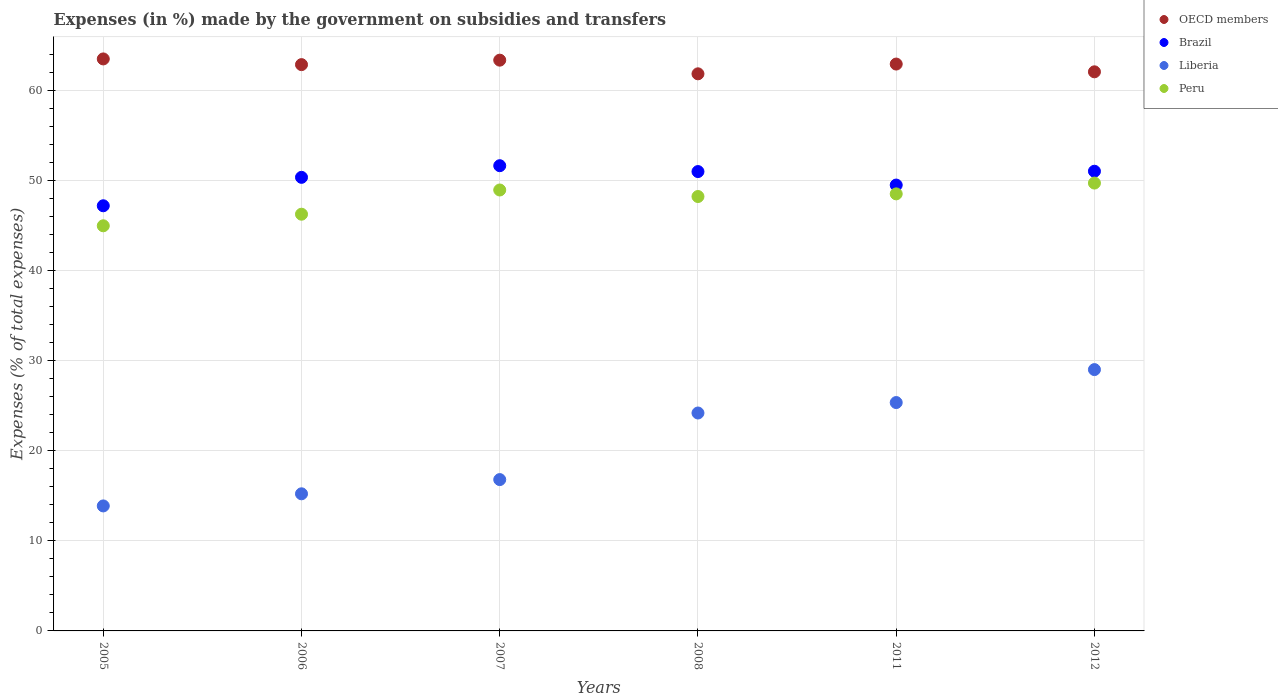How many different coloured dotlines are there?
Make the answer very short. 4. What is the percentage of expenses made by the government on subsidies and transfers in OECD members in 2005?
Your response must be concise. 63.48. Across all years, what is the maximum percentage of expenses made by the government on subsidies and transfers in Brazil?
Offer a very short reply. 51.63. Across all years, what is the minimum percentage of expenses made by the government on subsidies and transfers in Liberia?
Keep it short and to the point. 13.87. In which year was the percentage of expenses made by the government on subsidies and transfers in OECD members maximum?
Your answer should be compact. 2005. In which year was the percentage of expenses made by the government on subsidies and transfers in Liberia minimum?
Your answer should be compact. 2005. What is the total percentage of expenses made by the government on subsidies and transfers in Peru in the graph?
Your answer should be very brief. 286.57. What is the difference between the percentage of expenses made by the government on subsidies and transfers in Brazil in 2005 and that in 2006?
Provide a succinct answer. -3.16. What is the difference between the percentage of expenses made by the government on subsidies and transfers in OECD members in 2012 and the percentage of expenses made by the government on subsidies and transfers in Brazil in 2007?
Provide a short and direct response. 10.42. What is the average percentage of expenses made by the government on subsidies and transfers in Brazil per year?
Give a very brief answer. 50.11. In the year 2006, what is the difference between the percentage of expenses made by the government on subsidies and transfers in OECD members and percentage of expenses made by the government on subsidies and transfers in Brazil?
Your answer should be compact. 12.51. What is the ratio of the percentage of expenses made by the government on subsidies and transfers in OECD members in 2005 to that in 2006?
Offer a very short reply. 1.01. What is the difference between the highest and the second highest percentage of expenses made by the government on subsidies and transfers in Liberia?
Give a very brief answer. 3.66. What is the difference between the highest and the lowest percentage of expenses made by the government on subsidies and transfers in Peru?
Give a very brief answer. 4.74. Is the sum of the percentage of expenses made by the government on subsidies and transfers in OECD members in 2007 and 2008 greater than the maximum percentage of expenses made by the government on subsidies and transfers in Peru across all years?
Make the answer very short. Yes. Does the percentage of expenses made by the government on subsidies and transfers in Brazil monotonically increase over the years?
Your response must be concise. No. Is the percentage of expenses made by the government on subsidies and transfers in Peru strictly less than the percentage of expenses made by the government on subsidies and transfers in OECD members over the years?
Your response must be concise. Yes. Does the graph contain grids?
Offer a terse response. Yes. How are the legend labels stacked?
Give a very brief answer. Vertical. What is the title of the graph?
Offer a very short reply. Expenses (in %) made by the government on subsidies and transfers. Does "Ghana" appear as one of the legend labels in the graph?
Ensure brevity in your answer.  No. What is the label or title of the X-axis?
Offer a very short reply. Years. What is the label or title of the Y-axis?
Offer a terse response. Expenses (% of total expenses). What is the Expenses (% of total expenses) of OECD members in 2005?
Make the answer very short. 63.48. What is the Expenses (% of total expenses) of Brazil in 2005?
Keep it short and to the point. 47.18. What is the Expenses (% of total expenses) of Liberia in 2005?
Make the answer very short. 13.87. What is the Expenses (% of total expenses) in Peru in 2005?
Ensure brevity in your answer.  44.96. What is the Expenses (% of total expenses) in OECD members in 2006?
Provide a short and direct response. 62.85. What is the Expenses (% of total expenses) in Brazil in 2006?
Give a very brief answer. 50.34. What is the Expenses (% of total expenses) of Liberia in 2006?
Provide a succinct answer. 15.22. What is the Expenses (% of total expenses) in Peru in 2006?
Your answer should be very brief. 46.25. What is the Expenses (% of total expenses) of OECD members in 2007?
Offer a very short reply. 63.35. What is the Expenses (% of total expenses) in Brazil in 2007?
Offer a very short reply. 51.63. What is the Expenses (% of total expenses) in Liberia in 2007?
Make the answer very short. 16.8. What is the Expenses (% of total expenses) in Peru in 2007?
Your answer should be compact. 48.94. What is the Expenses (% of total expenses) in OECD members in 2008?
Offer a terse response. 61.83. What is the Expenses (% of total expenses) of Brazil in 2008?
Make the answer very short. 50.98. What is the Expenses (% of total expenses) of Liberia in 2008?
Offer a terse response. 24.19. What is the Expenses (% of total expenses) in Peru in 2008?
Keep it short and to the point. 48.21. What is the Expenses (% of total expenses) of OECD members in 2011?
Provide a succinct answer. 62.91. What is the Expenses (% of total expenses) of Brazil in 2011?
Your answer should be compact. 49.48. What is the Expenses (% of total expenses) of Liberia in 2011?
Your response must be concise. 25.34. What is the Expenses (% of total expenses) in Peru in 2011?
Give a very brief answer. 48.5. What is the Expenses (% of total expenses) in OECD members in 2012?
Provide a short and direct response. 62.05. What is the Expenses (% of total expenses) in Brazil in 2012?
Your response must be concise. 51.02. What is the Expenses (% of total expenses) of Liberia in 2012?
Offer a terse response. 29. What is the Expenses (% of total expenses) of Peru in 2012?
Make the answer very short. 49.7. Across all years, what is the maximum Expenses (% of total expenses) of OECD members?
Your answer should be compact. 63.48. Across all years, what is the maximum Expenses (% of total expenses) in Brazil?
Offer a terse response. 51.63. Across all years, what is the maximum Expenses (% of total expenses) in Liberia?
Offer a very short reply. 29. Across all years, what is the maximum Expenses (% of total expenses) of Peru?
Give a very brief answer. 49.7. Across all years, what is the minimum Expenses (% of total expenses) in OECD members?
Offer a terse response. 61.83. Across all years, what is the minimum Expenses (% of total expenses) of Brazil?
Keep it short and to the point. 47.18. Across all years, what is the minimum Expenses (% of total expenses) in Liberia?
Make the answer very short. 13.87. Across all years, what is the minimum Expenses (% of total expenses) of Peru?
Offer a very short reply. 44.96. What is the total Expenses (% of total expenses) of OECD members in the graph?
Keep it short and to the point. 376.47. What is the total Expenses (% of total expenses) in Brazil in the graph?
Make the answer very short. 300.64. What is the total Expenses (% of total expenses) in Liberia in the graph?
Offer a terse response. 124.42. What is the total Expenses (% of total expenses) in Peru in the graph?
Give a very brief answer. 286.57. What is the difference between the Expenses (% of total expenses) of OECD members in 2005 and that in 2006?
Offer a very short reply. 0.63. What is the difference between the Expenses (% of total expenses) of Brazil in 2005 and that in 2006?
Provide a short and direct response. -3.16. What is the difference between the Expenses (% of total expenses) in Liberia in 2005 and that in 2006?
Keep it short and to the point. -1.35. What is the difference between the Expenses (% of total expenses) in Peru in 2005 and that in 2006?
Provide a short and direct response. -1.29. What is the difference between the Expenses (% of total expenses) in OECD members in 2005 and that in 2007?
Give a very brief answer. 0.14. What is the difference between the Expenses (% of total expenses) of Brazil in 2005 and that in 2007?
Your response must be concise. -4.45. What is the difference between the Expenses (% of total expenses) of Liberia in 2005 and that in 2007?
Ensure brevity in your answer.  -2.92. What is the difference between the Expenses (% of total expenses) of Peru in 2005 and that in 2007?
Your answer should be very brief. -3.97. What is the difference between the Expenses (% of total expenses) in OECD members in 2005 and that in 2008?
Your answer should be compact. 1.65. What is the difference between the Expenses (% of total expenses) of Brazil in 2005 and that in 2008?
Keep it short and to the point. -3.8. What is the difference between the Expenses (% of total expenses) of Liberia in 2005 and that in 2008?
Your response must be concise. -10.31. What is the difference between the Expenses (% of total expenses) in Peru in 2005 and that in 2008?
Ensure brevity in your answer.  -3.25. What is the difference between the Expenses (% of total expenses) of OECD members in 2005 and that in 2011?
Offer a terse response. 0.57. What is the difference between the Expenses (% of total expenses) of Brazil in 2005 and that in 2011?
Make the answer very short. -2.3. What is the difference between the Expenses (% of total expenses) in Liberia in 2005 and that in 2011?
Make the answer very short. -11.47. What is the difference between the Expenses (% of total expenses) in Peru in 2005 and that in 2011?
Provide a short and direct response. -3.54. What is the difference between the Expenses (% of total expenses) of OECD members in 2005 and that in 2012?
Provide a short and direct response. 1.43. What is the difference between the Expenses (% of total expenses) of Brazil in 2005 and that in 2012?
Provide a succinct answer. -3.83. What is the difference between the Expenses (% of total expenses) of Liberia in 2005 and that in 2012?
Provide a succinct answer. -15.13. What is the difference between the Expenses (% of total expenses) of Peru in 2005 and that in 2012?
Your answer should be very brief. -4.74. What is the difference between the Expenses (% of total expenses) in OECD members in 2006 and that in 2007?
Offer a terse response. -0.5. What is the difference between the Expenses (% of total expenses) in Brazil in 2006 and that in 2007?
Provide a succinct answer. -1.29. What is the difference between the Expenses (% of total expenses) of Liberia in 2006 and that in 2007?
Provide a short and direct response. -1.58. What is the difference between the Expenses (% of total expenses) in Peru in 2006 and that in 2007?
Ensure brevity in your answer.  -2.69. What is the difference between the Expenses (% of total expenses) of OECD members in 2006 and that in 2008?
Your response must be concise. 1.02. What is the difference between the Expenses (% of total expenses) in Brazil in 2006 and that in 2008?
Offer a terse response. -0.64. What is the difference between the Expenses (% of total expenses) in Liberia in 2006 and that in 2008?
Offer a very short reply. -8.97. What is the difference between the Expenses (% of total expenses) in Peru in 2006 and that in 2008?
Your answer should be very brief. -1.96. What is the difference between the Expenses (% of total expenses) of OECD members in 2006 and that in 2011?
Give a very brief answer. -0.06. What is the difference between the Expenses (% of total expenses) of Brazil in 2006 and that in 2011?
Your answer should be very brief. 0.86. What is the difference between the Expenses (% of total expenses) in Liberia in 2006 and that in 2011?
Ensure brevity in your answer.  -10.13. What is the difference between the Expenses (% of total expenses) of Peru in 2006 and that in 2011?
Your response must be concise. -2.26. What is the difference between the Expenses (% of total expenses) of OECD members in 2006 and that in 2012?
Your answer should be compact. 0.8. What is the difference between the Expenses (% of total expenses) in Brazil in 2006 and that in 2012?
Your answer should be compact. -0.68. What is the difference between the Expenses (% of total expenses) in Liberia in 2006 and that in 2012?
Give a very brief answer. -13.79. What is the difference between the Expenses (% of total expenses) in Peru in 2006 and that in 2012?
Make the answer very short. -3.46. What is the difference between the Expenses (% of total expenses) of OECD members in 2007 and that in 2008?
Provide a succinct answer. 1.52. What is the difference between the Expenses (% of total expenses) in Brazil in 2007 and that in 2008?
Provide a succinct answer. 0.65. What is the difference between the Expenses (% of total expenses) of Liberia in 2007 and that in 2008?
Provide a short and direct response. -7.39. What is the difference between the Expenses (% of total expenses) of Peru in 2007 and that in 2008?
Make the answer very short. 0.72. What is the difference between the Expenses (% of total expenses) of OECD members in 2007 and that in 2011?
Ensure brevity in your answer.  0.43. What is the difference between the Expenses (% of total expenses) of Brazil in 2007 and that in 2011?
Give a very brief answer. 2.15. What is the difference between the Expenses (% of total expenses) in Liberia in 2007 and that in 2011?
Provide a succinct answer. -8.55. What is the difference between the Expenses (% of total expenses) of Peru in 2007 and that in 2011?
Your answer should be compact. 0.43. What is the difference between the Expenses (% of total expenses) in OECD members in 2007 and that in 2012?
Give a very brief answer. 1.29. What is the difference between the Expenses (% of total expenses) in Brazil in 2007 and that in 2012?
Provide a short and direct response. 0.61. What is the difference between the Expenses (% of total expenses) of Liberia in 2007 and that in 2012?
Provide a succinct answer. -12.21. What is the difference between the Expenses (% of total expenses) of Peru in 2007 and that in 2012?
Ensure brevity in your answer.  -0.77. What is the difference between the Expenses (% of total expenses) of OECD members in 2008 and that in 2011?
Your response must be concise. -1.08. What is the difference between the Expenses (% of total expenses) of Brazil in 2008 and that in 2011?
Your response must be concise. 1.5. What is the difference between the Expenses (% of total expenses) of Liberia in 2008 and that in 2011?
Provide a short and direct response. -1.16. What is the difference between the Expenses (% of total expenses) in Peru in 2008 and that in 2011?
Offer a terse response. -0.29. What is the difference between the Expenses (% of total expenses) in OECD members in 2008 and that in 2012?
Your answer should be compact. -0.22. What is the difference between the Expenses (% of total expenses) of Brazil in 2008 and that in 2012?
Make the answer very short. -0.04. What is the difference between the Expenses (% of total expenses) of Liberia in 2008 and that in 2012?
Make the answer very short. -4.82. What is the difference between the Expenses (% of total expenses) of Peru in 2008 and that in 2012?
Ensure brevity in your answer.  -1.49. What is the difference between the Expenses (% of total expenses) in OECD members in 2011 and that in 2012?
Provide a short and direct response. 0.86. What is the difference between the Expenses (% of total expenses) in Brazil in 2011 and that in 2012?
Give a very brief answer. -1.53. What is the difference between the Expenses (% of total expenses) in Liberia in 2011 and that in 2012?
Offer a terse response. -3.66. What is the difference between the Expenses (% of total expenses) in Peru in 2011 and that in 2012?
Provide a short and direct response. -1.2. What is the difference between the Expenses (% of total expenses) in OECD members in 2005 and the Expenses (% of total expenses) in Brazil in 2006?
Make the answer very short. 13.14. What is the difference between the Expenses (% of total expenses) of OECD members in 2005 and the Expenses (% of total expenses) of Liberia in 2006?
Your answer should be very brief. 48.26. What is the difference between the Expenses (% of total expenses) of OECD members in 2005 and the Expenses (% of total expenses) of Peru in 2006?
Your answer should be compact. 17.23. What is the difference between the Expenses (% of total expenses) in Brazil in 2005 and the Expenses (% of total expenses) in Liberia in 2006?
Keep it short and to the point. 31.97. What is the difference between the Expenses (% of total expenses) in Brazil in 2005 and the Expenses (% of total expenses) in Peru in 2006?
Make the answer very short. 0.94. What is the difference between the Expenses (% of total expenses) of Liberia in 2005 and the Expenses (% of total expenses) of Peru in 2006?
Keep it short and to the point. -32.38. What is the difference between the Expenses (% of total expenses) in OECD members in 2005 and the Expenses (% of total expenses) in Brazil in 2007?
Make the answer very short. 11.85. What is the difference between the Expenses (% of total expenses) of OECD members in 2005 and the Expenses (% of total expenses) of Liberia in 2007?
Provide a short and direct response. 46.69. What is the difference between the Expenses (% of total expenses) in OECD members in 2005 and the Expenses (% of total expenses) in Peru in 2007?
Make the answer very short. 14.55. What is the difference between the Expenses (% of total expenses) in Brazil in 2005 and the Expenses (% of total expenses) in Liberia in 2007?
Your answer should be very brief. 30.39. What is the difference between the Expenses (% of total expenses) in Brazil in 2005 and the Expenses (% of total expenses) in Peru in 2007?
Your answer should be very brief. -1.75. What is the difference between the Expenses (% of total expenses) in Liberia in 2005 and the Expenses (% of total expenses) in Peru in 2007?
Your answer should be very brief. -35.06. What is the difference between the Expenses (% of total expenses) of OECD members in 2005 and the Expenses (% of total expenses) of Brazil in 2008?
Your response must be concise. 12.5. What is the difference between the Expenses (% of total expenses) in OECD members in 2005 and the Expenses (% of total expenses) in Liberia in 2008?
Keep it short and to the point. 39.3. What is the difference between the Expenses (% of total expenses) in OECD members in 2005 and the Expenses (% of total expenses) in Peru in 2008?
Your answer should be very brief. 15.27. What is the difference between the Expenses (% of total expenses) of Brazil in 2005 and the Expenses (% of total expenses) of Liberia in 2008?
Make the answer very short. 23. What is the difference between the Expenses (% of total expenses) in Brazil in 2005 and the Expenses (% of total expenses) in Peru in 2008?
Your answer should be very brief. -1.03. What is the difference between the Expenses (% of total expenses) of Liberia in 2005 and the Expenses (% of total expenses) of Peru in 2008?
Keep it short and to the point. -34.34. What is the difference between the Expenses (% of total expenses) of OECD members in 2005 and the Expenses (% of total expenses) of Brazil in 2011?
Your answer should be very brief. 14. What is the difference between the Expenses (% of total expenses) of OECD members in 2005 and the Expenses (% of total expenses) of Liberia in 2011?
Your answer should be compact. 38.14. What is the difference between the Expenses (% of total expenses) in OECD members in 2005 and the Expenses (% of total expenses) in Peru in 2011?
Give a very brief answer. 14.98. What is the difference between the Expenses (% of total expenses) in Brazil in 2005 and the Expenses (% of total expenses) in Liberia in 2011?
Provide a short and direct response. 21.84. What is the difference between the Expenses (% of total expenses) of Brazil in 2005 and the Expenses (% of total expenses) of Peru in 2011?
Provide a short and direct response. -1.32. What is the difference between the Expenses (% of total expenses) of Liberia in 2005 and the Expenses (% of total expenses) of Peru in 2011?
Offer a very short reply. -34.63. What is the difference between the Expenses (% of total expenses) in OECD members in 2005 and the Expenses (% of total expenses) in Brazil in 2012?
Provide a short and direct response. 12.46. What is the difference between the Expenses (% of total expenses) of OECD members in 2005 and the Expenses (% of total expenses) of Liberia in 2012?
Your answer should be compact. 34.48. What is the difference between the Expenses (% of total expenses) of OECD members in 2005 and the Expenses (% of total expenses) of Peru in 2012?
Offer a terse response. 13.78. What is the difference between the Expenses (% of total expenses) of Brazil in 2005 and the Expenses (% of total expenses) of Liberia in 2012?
Offer a very short reply. 18.18. What is the difference between the Expenses (% of total expenses) in Brazil in 2005 and the Expenses (% of total expenses) in Peru in 2012?
Make the answer very short. -2.52. What is the difference between the Expenses (% of total expenses) of Liberia in 2005 and the Expenses (% of total expenses) of Peru in 2012?
Provide a short and direct response. -35.83. What is the difference between the Expenses (% of total expenses) in OECD members in 2006 and the Expenses (% of total expenses) in Brazil in 2007?
Offer a terse response. 11.22. What is the difference between the Expenses (% of total expenses) in OECD members in 2006 and the Expenses (% of total expenses) in Liberia in 2007?
Provide a succinct answer. 46.05. What is the difference between the Expenses (% of total expenses) in OECD members in 2006 and the Expenses (% of total expenses) in Peru in 2007?
Ensure brevity in your answer.  13.91. What is the difference between the Expenses (% of total expenses) in Brazil in 2006 and the Expenses (% of total expenses) in Liberia in 2007?
Your answer should be compact. 33.55. What is the difference between the Expenses (% of total expenses) in Brazil in 2006 and the Expenses (% of total expenses) in Peru in 2007?
Offer a very short reply. 1.41. What is the difference between the Expenses (% of total expenses) of Liberia in 2006 and the Expenses (% of total expenses) of Peru in 2007?
Keep it short and to the point. -33.72. What is the difference between the Expenses (% of total expenses) of OECD members in 2006 and the Expenses (% of total expenses) of Brazil in 2008?
Ensure brevity in your answer.  11.87. What is the difference between the Expenses (% of total expenses) of OECD members in 2006 and the Expenses (% of total expenses) of Liberia in 2008?
Provide a short and direct response. 38.66. What is the difference between the Expenses (% of total expenses) of OECD members in 2006 and the Expenses (% of total expenses) of Peru in 2008?
Offer a terse response. 14.64. What is the difference between the Expenses (% of total expenses) of Brazil in 2006 and the Expenses (% of total expenses) of Liberia in 2008?
Offer a very short reply. 26.16. What is the difference between the Expenses (% of total expenses) of Brazil in 2006 and the Expenses (% of total expenses) of Peru in 2008?
Give a very brief answer. 2.13. What is the difference between the Expenses (% of total expenses) in Liberia in 2006 and the Expenses (% of total expenses) in Peru in 2008?
Your answer should be very brief. -32.99. What is the difference between the Expenses (% of total expenses) of OECD members in 2006 and the Expenses (% of total expenses) of Brazil in 2011?
Ensure brevity in your answer.  13.37. What is the difference between the Expenses (% of total expenses) of OECD members in 2006 and the Expenses (% of total expenses) of Liberia in 2011?
Provide a succinct answer. 37.5. What is the difference between the Expenses (% of total expenses) in OECD members in 2006 and the Expenses (% of total expenses) in Peru in 2011?
Your response must be concise. 14.34. What is the difference between the Expenses (% of total expenses) of Brazil in 2006 and the Expenses (% of total expenses) of Liberia in 2011?
Make the answer very short. 25. What is the difference between the Expenses (% of total expenses) in Brazil in 2006 and the Expenses (% of total expenses) in Peru in 2011?
Ensure brevity in your answer.  1.84. What is the difference between the Expenses (% of total expenses) of Liberia in 2006 and the Expenses (% of total expenses) of Peru in 2011?
Provide a short and direct response. -33.29. What is the difference between the Expenses (% of total expenses) in OECD members in 2006 and the Expenses (% of total expenses) in Brazil in 2012?
Keep it short and to the point. 11.83. What is the difference between the Expenses (% of total expenses) of OECD members in 2006 and the Expenses (% of total expenses) of Liberia in 2012?
Offer a very short reply. 33.85. What is the difference between the Expenses (% of total expenses) of OECD members in 2006 and the Expenses (% of total expenses) of Peru in 2012?
Ensure brevity in your answer.  13.15. What is the difference between the Expenses (% of total expenses) in Brazil in 2006 and the Expenses (% of total expenses) in Liberia in 2012?
Keep it short and to the point. 21.34. What is the difference between the Expenses (% of total expenses) of Brazil in 2006 and the Expenses (% of total expenses) of Peru in 2012?
Make the answer very short. 0.64. What is the difference between the Expenses (% of total expenses) of Liberia in 2006 and the Expenses (% of total expenses) of Peru in 2012?
Ensure brevity in your answer.  -34.49. What is the difference between the Expenses (% of total expenses) of OECD members in 2007 and the Expenses (% of total expenses) of Brazil in 2008?
Offer a terse response. 12.36. What is the difference between the Expenses (% of total expenses) of OECD members in 2007 and the Expenses (% of total expenses) of Liberia in 2008?
Your answer should be very brief. 39.16. What is the difference between the Expenses (% of total expenses) in OECD members in 2007 and the Expenses (% of total expenses) in Peru in 2008?
Give a very brief answer. 15.13. What is the difference between the Expenses (% of total expenses) of Brazil in 2007 and the Expenses (% of total expenses) of Liberia in 2008?
Your response must be concise. 27.45. What is the difference between the Expenses (% of total expenses) in Brazil in 2007 and the Expenses (% of total expenses) in Peru in 2008?
Your answer should be very brief. 3.42. What is the difference between the Expenses (% of total expenses) of Liberia in 2007 and the Expenses (% of total expenses) of Peru in 2008?
Offer a very short reply. -31.42. What is the difference between the Expenses (% of total expenses) in OECD members in 2007 and the Expenses (% of total expenses) in Brazil in 2011?
Your answer should be compact. 13.86. What is the difference between the Expenses (% of total expenses) of OECD members in 2007 and the Expenses (% of total expenses) of Liberia in 2011?
Your answer should be compact. 38. What is the difference between the Expenses (% of total expenses) in OECD members in 2007 and the Expenses (% of total expenses) in Peru in 2011?
Give a very brief answer. 14.84. What is the difference between the Expenses (% of total expenses) in Brazil in 2007 and the Expenses (% of total expenses) in Liberia in 2011?
Ensure brevity in your answer.  26.29. What is the difference between the Expenses (% of total expenses) of Brazil in 2007 and the Expenses (% of total expenses) of Peru in 2011?
Provide a succinct answer. 3.13. What is the difference between the Expenses (% of total expenses) of Liberia in 2007 and the Expenses (% of total expenses) of Peru in 2011?
Provide a short and direct response. -31.71. What is the difference between the Expenses (% of total expenses) of OECD members in 2007 and the Expenses (% of total expenses) of Brazil in 2012?
Provide a short and direct response. 12.33. What is the difference between the Expenses (% of total expenses) of OECD members in 2007 and the Expenses (% of total expenses) of Liberia in 2012?
Ensure brevity in your answer.  34.34. What is the difference between the Expenses (% of total expenses) of OECD members in 2007 and the Expenses (% of total expenses) of Peru in 2012?
Give a very brief answer. 13.64. What is the difference between the Expenses (% of total expenses) in Brazil in 2007 and the Expenses (% of total expenses) in Liberia in 2012?
Ensure brevity in your answer.  22.63. What is the difference between the Expenses (% of total expenses) of Brazil in 2007 and the Expenses (% of total expenses) of Peru in 2012?
Provide a short and direct response. 1.93. What is the difference between the Expenses (% of total expenses) of Liberia in 2007 and the Expenses (% of total expenses) of Peru in 2012?
Keep it short and to the point. -32.91. What is the difference between the Expenses (% of total expenses) in OECD members in 2008 and the Expenses (% of total expenses) in Brazil in 2011?
Your answer should be very brief. 12.35. What is the difference between the Expenses (% of total expenses) in OECD members in 2008 and the Expenses (% of total expenses) in Liberia in 2011?
Keep it short and to the point. 36.48. What is the difference between the Expenses (% of total expenses) in OECD members in 2008 and the Expenses (% of total expenses) in Peru in 2011?
Ensure brevity in your answer.  13.32. What is the difference between the Expenses (% of total expenses) in Brazil in 2008 and the Expenses (% of total expenses) in Liberia in 2011?
Offer a terse response. 25.64. What is the difference between the Expenses (% of total expenses) in Brazil in 2008 and the Expenses (% of total expenses) in Peru in 2011?
Your answer should be very brief. 2.48. What is the difference between the Expenses (% of total expenses) of Liberia in 2008 and the Expenses (% of total expenses) of Peru in 2011?
Your answer should be compact. -24.32. What is the difference between the Expenses (% of total expenses) in OECD members in 2008 and the Expenses (% of total expenses) in Brazil in 2012?
Make the answer very short. 10.81. What is the difference between the Expenses (% of total expenses) in OECD members in 2008 and the Expenses (% of total expenses) in Liberia in 2012?
Keep it short and to the point. 32.83. What is the difference between the Expenses (% of total expenses) of OECD members in 2008 and the Expenses (% of total expenses) of Peru in 2012?
Ensure brevity in your answer.  12.12. What is the difference between the Expenses (% of total expenses) in Brazil in 2008 and the Expenses (% of total expenses) in Liberia in 2012?
Give a very brief answer. 21.98. What is the difference between the Expenses (% of total expenses) of Brazil in 2008 and the Expenses (% of total expenses) of Peru in 2012?
Offer a very short reply. 1.28. What is the difference between the Expenses (% of total expenses) in Liberia in 2008 and the Expenses (% of total expenses) in Peru in 2012?
Your response must be concise. -25.52. What is the difference between the Expenses (% of total expenses) of OECD members in 2011 and the Expenses (% of total expenses) of Brazil in 2012?
Ensure brevity in your answer.  11.89. What is the difference between the Expenses (% of total expenses) in OECD members in 2011 and the Expenses (% of total expenses) in Liberia in 2012?
Offer a very short reply. 33.91. What is the difference between the Expenses (% of total expenses) of OECD members in 2011 and the Expenses (% of total expenses) of Peru in 2012?
Offer a very short reply. 13.21. What is the difference between the Expenses (% of total expenses) of Brazil in 2011 and the Expenses (% of total expenses) of Liberia in 2012?
Ensure brevity in your answer.  20.48. What is the difference between the Expenses (% of total expenses) in Brazil in 2011 and the Expenses (% of total expenses) in Peru in 2012?
Offer a very short reply. -0.22. What is the difference between the Expenses (% of total expenses) in Liberia in 2011 and the Expenses (% of total expenses) in Peru in 2012?
Provide a succinct answer. -24.36. What is the average Expenses (% of total expenses) of OECD members per year?
Your answer should be very brief. 62.75. What is the average Expenses (% of total expenses) in Brazil per year?
Offer a very short reply. 50.11. What is the average Expenses (% of total expenses) of Liberia per year?
Offer a terse response. 20.74. What is the average Expenses (% of total expenses) of Peru per year?
Your answer should be compact. 47.76. In the year 2005, what is the difference between the Expenses (% of total expenses) of OECD members and Expenses (% of total expenses) of Brazil?
Provide a short and direct response. 16.3. In the year 2005, what is the difference between the Expenses (% of total expenses) of OECD members and Expenses (% of total expenses) of Liberia?
Provide a succinct answer. 49.61. In the year 2005, what is the difference between the Expenses (% of total expenses) of OECD members and Expenses (% of total expenses) of Peru?
Provide a short and direct response. 18.52. In the year 2005, what is the difference between the Expenses (% of total expenses) of Brazil and Expenses (% of total expenses) of Liberia?
Offer a terse response. 33.31. In the year 2005, what is the difference between the Expenses (% of total expenses) in Brazil and Expenses (% of total expenses) in Peru?
Provide a succinct answer. 2.22. In the year 2005, what is the difference between the Expenses (% of total expenses) in Liberia and Expenses (% of total expenses) in Peru?
Keep it short and to the point. -31.09. In the year 2006, what is the difference between the Expenses (% of total expenses) in OECD members and Expenses (% of total expenses) in Brazil?
Your answer should be very brief. 12.51. In the year 2006, what is the difference between the Expenses (% of total expenses) in OECD members and Expenses (% of total expenses) in Liberia?
Provide a short and direct response. 47.63. In the year 2006, what is the difference between the Expenses (% of total expenses) of OECD members and Expenses (% of total expenses) of Peru?
Your answer should be very brief. 16.6. In the year 2006, what is the difference between the Expenses (% of total expenses) of Brazil and Expenses (% of total expenses) of Liberia?
Provide a short and direct response. 35.12. In the year 2006, what is the difference between the Expenses (% of total expenses) in Brazil and Expenses (% of total expenses) in Peru?
Make the answer very short. 4.09. In the year 2006, what is the difference between the Expenses (% of total expenses) of Liberia and Expenses (% of total expenses) of Peru?
Your answer should be very brief. -31.03. In the year 2007, what is the difference between the Expenses (% of total expenses) in OECD members and Expenses (% of total expenses) in Brazil?
Offer a very short reply. 11.71. In the year 2007, what is the difference between the Expenses (% of total expenses) of OECD members and Expenses (% of total expenses) of Liberia?
Offer a terse response. 46.55. In the year 2007, what is the difference between the Expenses (% of total expenses) in OECD members and Expenses (% of total expenses) in Peru?
Offer a terse response. 14.41. In the year 2007, what is the difference between the Expenses (% of total expenses) in Brazil and Expenses (% of total expenses) in Liberia?
Keep it short and to the point. 34.84. In the year 2007, what is the difference between the Expenses (% of total expenses) in Brazil and Expenses (% of total expenses) in Peru?
Give a very brief answer. 2.7. In the year 2007, what is the difference between the Expenses (% of total expenses) in Liberia and Expenses (% of total expenses) in Peru?
Ensure brevity in your answer.  -32.14. In the year 2008, what is the difference between the Expenses (% of total expenses) of OECD members and Expenses (% of total expenses) of Brazil?
Your response must be concise. 10.85. In the year 2008, what is the difference between the Expenses (% of total expenses) of OECD members and Expenses (% of total expenses) of Liberia?
Ensure brevity in your answer.  37.64. In the year 2008, what is the difference between the Expenses (% of total expenses) of OECD members and Expenses (% of total expenses) of Peru?
Make the answer very short. 13.62. In the year 2008, what is the difference between the Expenses (% of total expenses) of Brazil and Expenses (% of total expenses) of Liberia?
Offer a very short reply. 26.8. In the year 2008, what is the difference between the Expenses (% of total expenses) of Brazil and Expenses (% of total expenses) of Peru?
Keep it short and to the point. 2.77. In the year 2008, what is the difference between the Expenses (% of total expenses) of Liberia and Expenses (% of total expenses) of Peru?
Provide a short and direct response. -24.03. In the year 2011, what is the difference between the Expenses (% of total expenses) of OECD members and Expenses (% of total expenses) of Brazil?
Provide a succinct answer. 13.43. In the year 2011, what is the difference between the Expenses (% of total expenses) in OECD members and Expenses (% of total expenses) in Liberia?
Offer a terse response. 37.57. In the year 2011, what is the difference between the Expenses (% of total expenses) of OECD members and Expenses (% of total expenses) of Peru?
Your response must be concise. 14.41. In the year 2011, what is the difference between the Expenses (% of total expenses) of Brazil and Expenses (% of total expenses) of Liberia?
Your answer should be compact. 24.14. In the year 2011, what is the difference between the Expenses (% of total expenses) in Brazil and Expenses (% of total expenses) in Peru?
Ensure brevity in your answer.  0.98. In the year 2011, what is the difference between the Expenses (% of total expenses) of Liberia and Expenses (% of total expenses) of Peru?
Make the answer very short. -23.16. In the year 2012, what is the difference between the Expenses (% of total expenses) of OECD members and Expenses (% of total expenses) of Brazil?
Provide a succinct answer. 11.03. In the year 2012, what is the difference between the Expenses (% of total expenses) in OECD members and Expenses (% of total expenses) in Liberia?
Provide a succinct answer. 33.05. In the year 2012, what is the difference between the Expenses (% of total expenses) of OECD members and Expenses (% of total expenses) of Peru?
Keep it short and to the point. 12.35. In the year 2012, what is the difference between the Expenses (% of total expenses) in Brazil and Expenses (% of total expenses) in Liberia?
Give a very brief answer. 22.01. In the year 2012, what is the difference between the Expenses (% of total expenses) of Brazil and Expenses (% of total expenses) of Peru?
Keep it short and to the point. 1.31. In the year 2012, what is the difference between the Expenses (% of total expenses) of Liberia and Expenses (% of total expenses) of Peru?
Offer a very short reply. -20.7. What is the ratio of the Expenses (% of total expenses) in OECD members in 2005 to that in 2006?
Your answer should be compact. 1.01. What is the ratio of the Expenses (% of total expenses) in Brazil in 2005 to that in 2006?
Your answer should be very brief. 0.94. What is the ratio of the Expenses (% of total expenses) of Liberia in 2005 to that in 2006?
Keep it short and to the point. 0.91. What is the ratio of the Expenses (% of total expenses) in Peru in 2005 to that in 2006?
Provide a short and direct response. 0.97. What is the ratio of the Expenses (% of total expenses) of OECD members in 2005 to that in 2007?
Your response must be concise. 1. What is the ratio of the Expenses (% of total expenses) in Brazil in 2005 to that in 2007?
Your response must be concise. 0.91. What is the ratio of the Expenses (% of total expenses) of Liberia in 2005 to that in 2007?
Give a very brief answer. 0.83. What is the ratio of the Expenses (% of total expenses) in Peru in 2005 to that in 2007?
Your answer should be compact. 0.92. What is the ratio of the Expenses (% of total expenses) in OECD members in 2005 to that in 2008?
Offer a very short reply. 1.03. What is the ratio of the Expenses (% of total expenses) of Brazil in 2005 to that in 2008?
Keep it short and to the point. 0.93. What is the ratio of the Expenses (% of total expenses) in Liberia in 2005 to that in 2008?
Give a very brief answer. 0.57. What is the ratio of the Expenses (% of total expenses) in Peru in 2005 to that in 2008?
Your answer should be very brief. 0.93. What is the ratio of the Expenses (% of total expenses) of OECD members in 2005 to that in 2011?
Make the answer very short. 1.01. What is the ratio of the Expenses (% of total expenses) of Brazil in 2005 to that in 2011?
Ensure brevity in your answer.  0.95. What is the ratio of the Expenses (% of total expenses) in Liberia in 2005 to that in 2011?
Offer a terse response. 0.55. What is the ratio of the Expenses (% of total expenses) of Peru in 2005 to that in 2011?
Your answer should be compact. 0.93. What is the ratio of the Expenses (% of total expenses) in OECD members in 2005 to that in 2012?
Provide a short and direct response. 1.02. What is the ratio of the Expenses (% of total expenses) of Brazil in 2005 to that in 2012?
Make the answer very short. 0.92. What is the ratio of the Expenses (% of total expenses) of Liberia in 2005 to that in 2012?
Offer a very short reply. 0.48. What is the ratio of the Expenses (% of total expenses) in Peru in 2005 to that in 2012?
Provide a short and direct response. 0.9. What is the ratio of the Expenses (% of total expenses) of OECD members in 2006 to that in 2007?
Provide a short and direct response. 0.99. What is the ratio of the Expenses (% of total expenses) of Liberia in 2006 to that in 2007?
Offer a very short reply. 0.91. What is the ratio of the Expenses (% of total expenses) of Peru in 2006 to that in 2007?
Your response must be concise. 0.95. What is the ratio of the Expenses (% of total expenses) of OECD members in 2006 to that in 2008?
Offer a terse response. 1.02. What is the ratio of the Expenses (% of total expenses) in Brazil in 2006 to that in 2008?
Your answer should be very brief. 0.99. What is the ratio of the Expenses (% of total expenses) in Liberia in 2006 to that in 2008?
Offer a very short reply. 0.63. What is the ratio of the Expenses (% of total expenses) of Peru in 2006 to that in 2008?
Keep it short and to the point. 0.96. What is the ratio of the Expenses (% of total expenses) of Brazil in 2006 to that in 2011?
Your response must be concise. 1.02. What is the ratio of the Expenses (% of total expenses) in Liberia in 2006 to that in 2011?
Offer a terse response. 0.6. What is the ratio of the Expenses (% of total expenses) of Peru in 2006 to that in 2011?
Your answer should be compact. 0.95. What is the ratio of the Expenses (% of total expenses) in OECD members in 2006 to that in 2012?
Your answer should be very brief. 1.01. What is the ratio of the Expenses (% of total expenses) of Brazil in 2006 to that in 2012?
Provide a short and direct response. 0.99. What is the ratio of the Expenses (% of total expenses) of Liberia in 2006 to that in 2012?
Offer a very short reply. 0.52. What is the ratio of the Expenses (% of total expenses) of Peru in 2006 to that in 2012?
Provide a succinct answer. 0.93. What is the ratio of the Expenses (% of total expenses) of OECD members in 2007 to that in 2008?
Offer a very short reply. 1.02. What is the ratio of the Expenses (% of total expenses) of Brazil in 2007 to that in 2008?
Keep it short and to the point. 1.01. What is the ratio of the Expenses (% of total expenses) in Liberia in 2007 to that in 2008?
Give a very brief answer. 0.69. What is the ratio of the Expenses (% of total expenses) of OECD members in 2007 to that in 2011?
Make the answer very short. 1.01. What is the ratio of the Expenses (% of total expenses) in Brazil in 2007 to that in 2011?
Provide a succinct answer. 1.04. What is the ratio of the Expenses (% of total expenses) in Liberia in 2007 to that in 2011?
Ensure brevity in your answer.  0.66. What is the ratio of the Expenses (% of total expenses) in Peru in 2007 to that in 2011?
Provide a succinct answer. 1.01. What is the ratio of the Expenses (% of total expenses) of OECD members in 2007 to that in 2012?
Your answer should be compact. 1.02. What is the ratio of the Expenses (% of total expenses) of Liberia in 2007 to that in 2012?
Offer a very short reply. 0.58. What is the ratio of the Expenses (% of total expenses) in Peru in 2007 to that in 2012?
Your response must be concise. 0.98. What is the ratio of the Expenses (% of total expenses) in OECD members in 2008 to that in 2011?
Give a very brief answer. 0.98. What is the ratio of the Expenses (% of total expenses) of Brazil in 2008 to that in 2011?
Offer a very short reply. 1.03. What is the ratio of the Expenses (% of total expenses) in Liberia in 2008 to that in 2011?
Make the answer very short. 0.95. What is the ratio of the Expenses (% of total expenses) of Brazil in 2008 to that in 2012?
Offer a very short reply. 1. What is the ratio of the Expenses (% of total expenses) in Liberia in 2008 to that in 2012?
Provide a succinct answer. 0.83. What is the ratio of the Expenses (% of total expenses) of Peru in 2008 to that in 2012?
Ensure brevity in your answer.  0.97. What is the ratio of the Expenses (% of total expenses) in OECD members in 2011 to that in 2012?
Keep it short and to the point. 1.01. What is the ratio of the Expenses (% of total expenses) in Brazil in 2011 to that in 2012?
Provide a succinct answer. 0.97. What is the ratio of the Expenses (% of total expenses) in Liberia in 2011 to that in 2012?
Your answer should be very brief. 0.87. What is the ratio of the Expenses (% of total expenses) of Peru in 2011 to that in 2012?
Offer a very short reply. 0.98. What is the difference between the highest and the second highest Expenses (% of total expenses) in OECD members?
Provide a succinct answer. 0.14. What is the difference between the highest and the second highest Expenses (% of total expenses) of Brazil?
Provide a succinct answer. 0.61. What is the difference between the highest and the second highest Expenses (% of total expenses) of Liberia?
Your answer should be compact. 3.66. What is the difference between the highest and the second highest Expenses (% of total expenses) of Peru?
Offer a very short reply. 0.77. What is the difference between the highest and the lowest Expenses (% of total expenses) of OECD members?
Provide a succinct answer. 1.65. What is the difference between the highest and the lowest Expenses (% of total expenses) in Brazil?
Offer a terse response. 4.45. What is the difference between the highest and the lowest Expenses (% of total expenses) of Liberia?
Make the answer very short. 15.13. What is the difference between the highest and the lowest Expenses (% of total expenses) of Peru?
Your response must be concise. 4.74. 